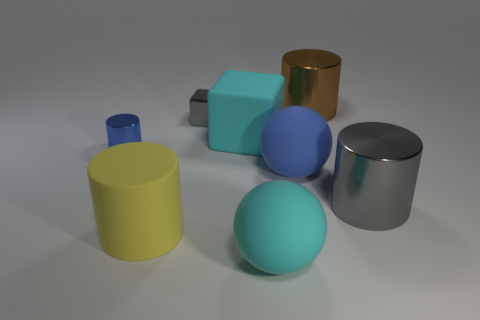Subtract 1 cylinders. How many cylinders are left? 3 Subtract all green cylinders. Subtract all yellow blocks. How many cylinders are left? 4 Add 2 large cyan cubes. How many objects exist? 10 Subtract all blocks. How many objects are left? 6 Add 3 big rubber cylinders. How many big rubber cylinders exist? 4 Subtract 0 red balls. How many objects are left? 8 Subtract all blue shiny blocks. Subtract all small cylinders. How many objects are left? 7 Add 5 big blue objects. How many big blue objects are left? 6 